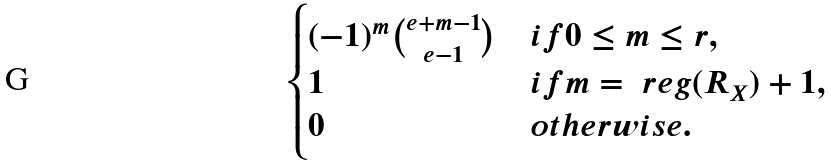<formula> <loc_0><loc_0><loc_500><loc_500>\begin{cases} ( - 1 ) ^ { m } \binom { e + m - 1 } { e - 1 } & i f 0 \leq m \leq r , \\ 1 & i f m = \ r e g ( R _ { X } ) + 1 , \\ 0 & o t h e r w i s e . \end{cases}</formula> 